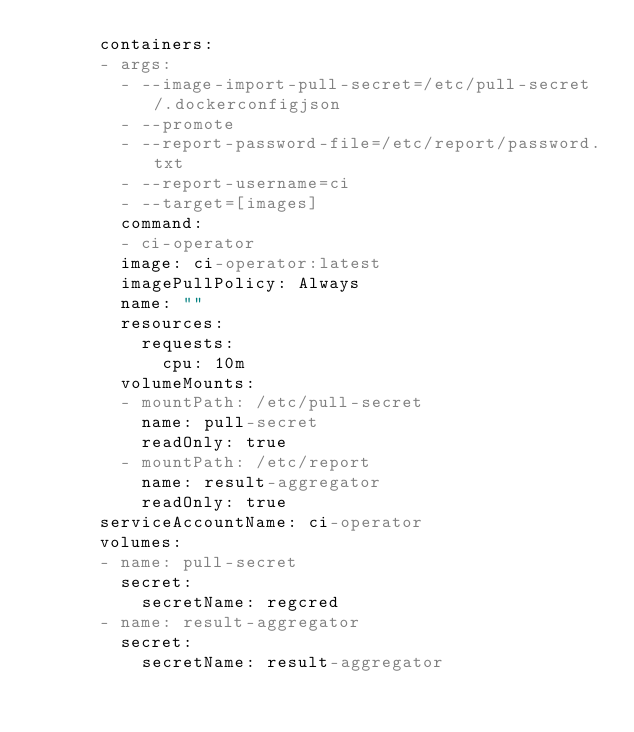<code> <loc_0><loc_0><loc_500><loc_500><_YAML_>      containers:
      - args:
        - --image-import-pull-secret=/etc/pull-secret/.dockerconfigjson
        - --promote
        - --report-password-file=/etc/report/password.txt
        - --report-username=ci
        - --target=[images]
        command:
        - ci-operator
        image: ci-operator:latest
        imagePullPolicy: Always
        name: ""
        resources:
          requests:
            cpu: 10m
        volumeMounts:
        - mountPath: /etc/pull-secret
          name: pull-secret
          readOnly: true
        - mountPath: /etc/report
          name: result-aggregator
          readOnly: true
      serviceAccountName: ci-operator
      volumes:
      - name: pull-secret
        secret:
          secretName: regcred
      - name: result-aggregator
        secret:
          secretName: result-aggregator
</code> 